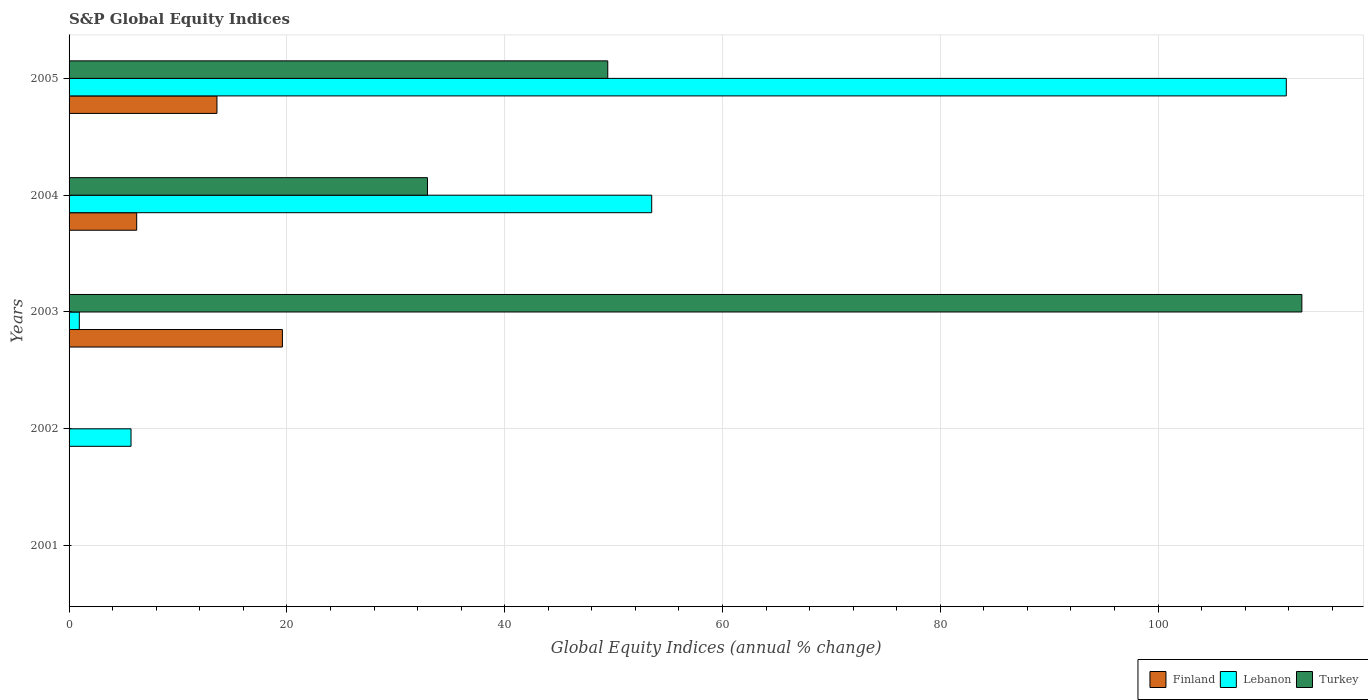How many different coloured bars are there?
Your answer should be very brief. 3. What is the label of the 3rd group of bars from the top?
Offer a terse response. 2003. What is the global equity indices in Finland in 2001?
Offer a very short reply. 0. Across all years, what is the maximum global equity indices in Finland?
Your response must be concise. 19.59. Across all years, what is the minimum global equity indices in Lebanon?
Your answer should be very brief. 0. What is the total global equity indices in Turkey in the graph?
Offer a very short reply. 195.58. What is the difference between the global equity indices in Finland in 2003 and that in 2004?
Give a very brief answer. 13.38. What is the difference between the global equity indices in Finland in 2003 and the global equity indices in Turkey in 2002?
Give a very brief answer. 19.59. What is the average global equity indices in Lebanon per year?
Provide a succinct answer. 34.38. In the year 2005, what is the difference between the global equity indices in Finland and global equity indices in Turkey?
Keep it short and to the point. -35.89. What is the ratio of the global equity indices in Lebanon in 2003 to that in 2004?
Give a very brief answer. 0.02. Is the difference between the global equity indices in Finland in 2003 and 2004 greater than the difference between the global equity indices in Turkey in 2003 and 2004?
Your answer should be compact. No. What is the difference between the highest and the second highest global equity indices in Finland?
Ensure brevity in your answer.  6.01. What is the difference between the highest and the lowest global equity indices in Turkey?
Your response must be concise. 113.2. Is the sum of the global equity indices in Lebanon in 2002 and 2003 greater than the maximum global equity indices in Finland across all years?
Offer a very short reply. No. How many years are there in the graph?
Offer a very short reply. 5. Are the values on the major ticks of X-axis written in scientific E-notation?
Offer a very short reply. No. Does the graph contain any zero values?
Ensure brevity in your answer.  Yes. Where does the legend appear in the graph?
Make the answer very short. Bottom right. What is the title of the graph?
Provide a short and direct response. S&P Global Equity Indices. What is the label or title of the X-axis?
Make the answer very short. Global Equity Indices (annual % change). What is the Global Equity Indices (annual % change) in Finland in 2001?
Provide a short and direct response. 0. What is the Global Equity Indices (annual % change) of Turkey in 2001?
Ensure brevity in your answer.  0. What is the Global Equity Indices (annual % change) in Finland in 2002?
Provide a short and direct response. 0. What is the Global Equity Indices (annual % change) in Lebanon in 2002?
Give a very brief answer. 5.69. What is the Global Equity Indices (annual % change) of Finland in 2003?
Give a very brief answer. 19.59. What is the Global Equity Indices (annual % change) of Lebanon in 2003?
Your answer should be very brief. 0.94. What is the Global Equity Indices (annual % change) of Turkey in 2003?
Give a very brief answer. 113.2. What is the Global Equity Indices (annual % change) of Finland in 2004?
Your response must be concise. 6.21. What is the Global Equity Indices (annual % change) of Lebanon in 2004?
Offer a very short reply. 53.5. What is the Global Equity Indices (annual % change) in Turkey in 2004?
Provide a succinct answer. 32.91. What is the Global Equity Indices (annual % change) in Finland in 2005?
Offer a terse response. 13.58. What is the Global Equity Indices (annual % change) of Lebanon in 2005?
Provide a short and direct response. 111.77. What is the Global Equity Indices (annual % change) in Turkey in 2005?
Offer a very short reply. 49.47. Across all years, what is the maximum Global Equity Indices (annual % change) of Finland?
Keep it short and to the point. 19.59. Across all years, what is the maximum Global Equity Indices (annual % change) in Lebanon?
Your answer should be very brief. 111.77. Across all years, what is the maximum Global Equity Indices (annual % change) of Turkey?
Give a very brief answer. 113.2. Across all years, what is the minimum Global Equity Indices (annual % change) in Finland?
Ensure brevity in your answer.  0. What is the total Global Equity Indices (annual % change) of Finland in the graph?
Keep it short and to the point. 39.38. What is the total Global Equity Indices (annual % change) in Lebanon in the graph?
Provide a succinct answer. 171.9. What is the total Global Equity Indices (annual % change) of Turkey in the graph?
Offer a very short reply. 195.58. What is the difference between the Global Equity Indices (annual % change) in Lebanon in 2002 and that in 2003?
Your answer should be compact. 4.75. What is the difference between the Global Equity Indices (annual % change) of Lebanon in 2002 and that in 2004?
Provide a succinct answer. -47.81. What is the difference between the Global Equity Indices (annual % change) of Lebanon in 2002 and that in 2005?
Offer a terse response. -106.08. What is the difference between the Global Equity Indices (annual % change) in Finland in 2003 and that in 2004?
Your response must be concise. 13.38. What is the difference between the Global Equity Indices (annual % change) in Lebanon in 2003 and that in 2004?
Your response must be concise. -52.56. What is the difference between the Global Equity Indices (annual % change) in Turkey in 2003 and that in 2004?
Give a very brief answer. 80.29. What is the difference between the Global Equity Indices (annual % change) in Finland in 2003 and that in 2005?
Provide a succinct answer. 6.01. What is the difference between the Global Equity Indices (annual % change) in Lebanon in 2003 and that in 2005?
Offer a very short reply. -110.83. What is the difference between the Global Equity Indices (annual % change) in Turkey in 2003 and that in 2005?
Your answer should be compact. 63.73. What is the difference between the Global Equity Indices (annual % change) of Finland in 2004 and that in 2005?
Ensure brevity in your answer.  -7.37. What is the difference between the Global Equity Indices (annual % change) of Lebanon in 2004 and that in 2005?
Offer a very short reply. -58.27. What is the difference between the Global Equity Indices (annual % change) in Turkey in 2004 and that in 2005?
Offer a terse response. -16.56. What is the difference between the Global Equity Indices (annual % change) in Lebanon in 2002 and the Global Equity Indices (annual % change) in Turkey in 2003?
Keep it short and to the point. -107.51. What is the difference between the Global Equity Indices (annual % change) in Lebanon in 2002 and the Global Equity Indices (annual % change) in Turkey in 2004?
Your answer should be compact. -27.22. What is the difference between the Global Equity Indices (annual % change) in Lebanon in 2002 and the Global Equity Indices (annual % change) in Turkey in 2005?
Ensure brevity in your answer.  -43.78. What is the difference between the Global Equity Indices (annual % change) in Finland in 2003 and the Global Equity Indices (annual % change) in Lebanon in 2004?
Offer a very short reply. -33.91. What is the difference between the Global Equity Indices (annual % change) of Finland in 2003 and the Global Equity Indices (annual % change) of Turkey in 2004?
Your answer should be very brief. -13.32. What is the difference between the Global Equity Indices (annual % change) in Lebanon in 2003 and the Global Equity Indices (annual % change) in Turkey in 2004?
Your answer should be compact. -31.97. What is the difference between the Global Equity Indices (annual % change) of Finland in 2003 and the Global Equity Indices (annual % change) of Lebanon in 2005?
Offer a very short reply. -92.18. What is the difference between the Global Equity Indices (annual % change) in Finland in 2003 and the Global Equity Indices (annual % change) in Turkey in 2005?
Your response must be concise. -29.88. What is the difference between the Global Equity Indices (annual % change) in Lebanon in 2003 and the Global Equity Indices (annual % change) in Turkey in 2005?
Offer a terse response. -48.53. What is the difference between the Global Equity Indices (annual % change) in Finland in 2004 and the Global Equity Indices (annual % change) in Lebanon in 2005?
Keep it short and to the point. -105.56. What is the difference between the Global Equity Indices (annual % change) of Finland in 2004 and the Global Equity Indices (annual % change) of Turkey in 2005?
Your response must be concise. -43.26. What is the difference between the Global Equity Indices (annual % change) in Lebanon in 2004 and the Global Equity Indices (annual % change) in Turkey in 2005?
Ensure brevity in your answer.  4.03. What is the average Global Equity Indices (annual % change) of Finland per year?
Keep it short and to the point. 7.88. What is the average Global Equity Indices (annual % change) in Lebanon per year?
Keep it short and to the point. 34.38. What is the average Global Equity Indices (annual % change) in Turkey per year?
Keep it short and to the point. 39.12. In the year 2003, what is the difference between the Global Equity Indices (annual % change) in Finland and Global Equity Indices (annual % change) in Lebanon?
Your response must be concise. 18.65. In the year 2003, what is the difference between the Global Equity Indices (annual % change) in Finland and Global Equity Indices (annual % change) in Turkey?
Your answer should be very brief. -93.61. In the year 2003, what is the difference between the Global Equity Indices (annual % change) of Lebanon and Global Equity Indices (annual % change) of Turkey?
Your response must be concise. -112.26. In the year 2004, what is the difference between the Global Equity Indices (annual % change) in Finland and Global Equity Indices (annual % change) in Lebanon?
Keep it short and to the point. -47.29. In the year 2004, what is the difference between the Global Equity Indices (annual % change) in Finland and Global Equity Indices (annual % change) in Turkey?
Keep it short and to the point. -26.7. In the year 2004, what is the difference between the Global Equity Indices (annual % change) in Lebanon and Global Equity Indices (annual % change) in Turkey?
Your response must be concise. 20.59. In the year 2005, what is the difference between the Global Equity Indices (annual % change) in Finland and Global Equity Indices (annual % change) in Lebanon?
Offer a terse response. -98.19. In the year 2005, what is the difference between the Global Equity Indices (annual % change) in Finland and Global Equity Indices (annual % change) in Turkey?
Make the answer very short. -35.89. In the year 2005, what is the difference between the Global Equity Indices (annual % change) of Lebanon and Global Equity Indices (annual % change) of Turkey?
Provide a succinct answer. 62.31. What is the ratio of the Global Equity Indices (annual % change) of Lebanon in 2002 to that in 2003?
Make the answer very short. 6.05. What is the ratio of the Global Equity Indices (annual % change) of Lebanon in 2002 to that in 2004?
Ensure brevity in your answer.  0.11. What is the ratio of the Global Equity Indices (annual % change) of Lebanon in 2002 to that in 2005?
Ensure brevity in your answer.  0.05. What is the ratio of the Global Equity Indices (annual % change) of Finland in 2003 to that in 2004?
Ensure brevity in your answer.  3.15. What is the ratio of the Global Equity Indices (annual % change) in Lebanon in 2003 to that in 2004?
Provide a succinct answer. 0.02. What is the ratio of the Global Equity Indices (annual % change) of Turkey in 2003 to that in 2004?
Offer a terse response. 3.44. What is the ratio of the Global Equity Indices (annual % change) of Finland in 2003 to that in 2005?
Provide a short and direct response. 1.44. What is the ratio of the Global Equity Indices (annual % change) of Lebanon in 2003 to that in 2005?
Keep it short and to the point. 0.01. What is the ratio of the Global Equity Indices (annual % change) in Turkey in 2003 to that in 2005?
Your answer should be compact. 2.29. What is the ratio of the Global Equity Indices (annual % change) of Finland in 2004 to that in 2005?
Your answer should be very brief. 0.46. What is the ratio of the Global Equity Indices (annual % change) in Lebanon in 2004 to that in 2005?
Make the answer very short. 0.48. What is the ratio of the Global Equity Indices (annual % change) of Turkey in 2004 to that in 2005?
Offer a terse response. 0.67. What is the difference between the highest and the second highest Global Equity Indices (annual % change) of Finland?
Give a very brief answer. 6.01. What is the difference between the highest and the second highest Global Equity Indices (annual % change) of Lebanon?
Ensure brevity in your answer.  58.27. What is the difference between the highest and the second highest Global Equity Indices (annual % change) of Turkey?
Your answer should be compact. 63.73. What is the difference between the highest and the lowest Global Equity Indices (annual % change) of Finland?
Offer a very short reply. 19.59. What is the difference between the highest and the lowest Global Equity Indices (annual % change) of Lebanon?
Your answer should be compact. 111.77. What is the difference between the highest and the lowest Global Equity Indices (annual % change) in Turkey?
Ensure brevity in your answer.  113.2. 